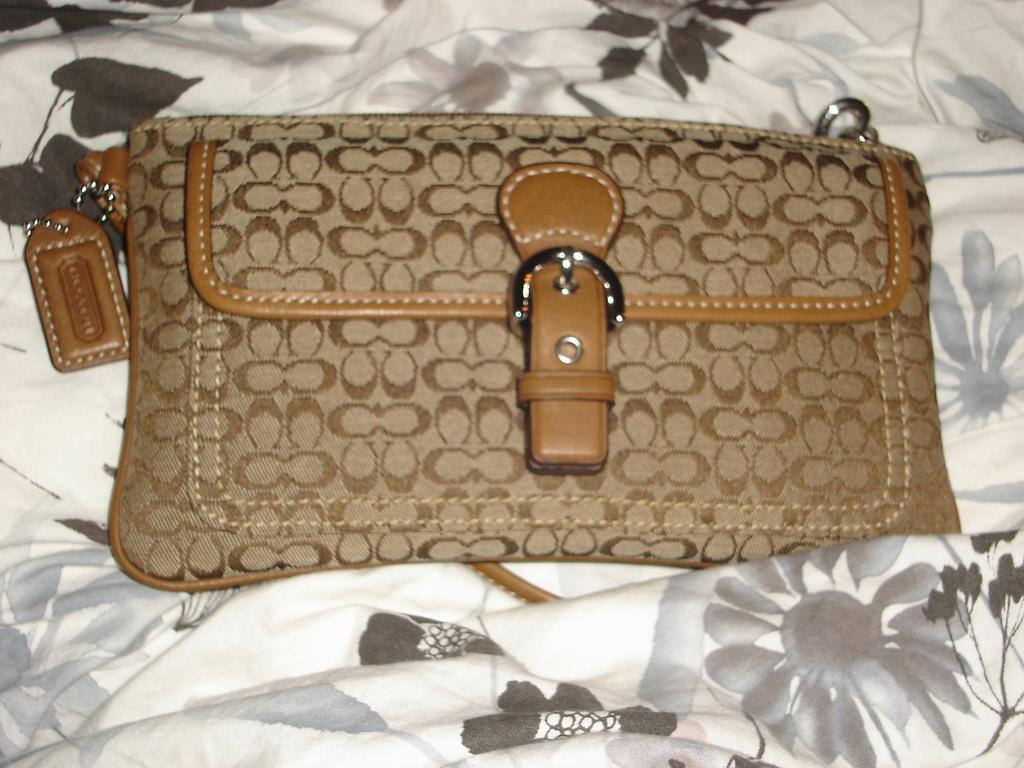In one or two sentences, can you explain what this image depicts? Here we see a handbag 